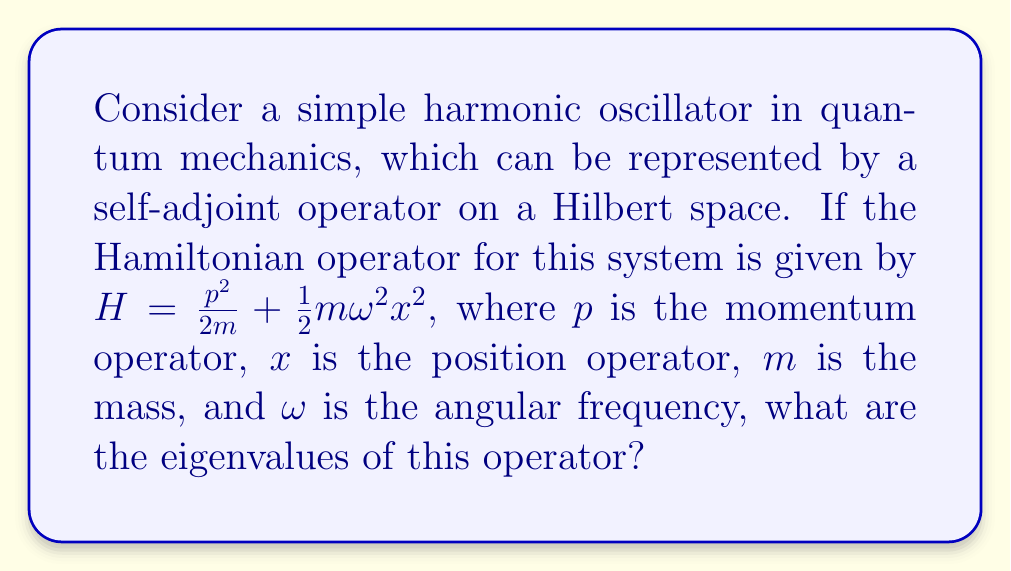Could you help me with this problem? To find the eigenvalues of the Hamiltonian operator, we need to perform a spectral decomposition:

1) The Hamiltonian $H = \frac{p^2}{2m} + \frac{1}{2}m\omega^2x^2$ is a self-adjoint operator on the Hilbert space of square-integrable functions.

2) For the harmonic oscillator, it's known that the eigenvalue equation is:

   $$H\psi_n = E_n\psi_n$$

   where $\psi_n$ are the eigenfunctions and $E_n$ are the eigenvalues.

3) The solution to this equation gives the eigenvalues:

   $$E_n = \hbar\omega(n + \frac{1}{2})$$

   where $n = 0, 1, 2, ...$

4) This means that the energy levels of the harmonic oscillator are quantized, with the lowest energy level (ground state) at $\frac{1}{2}\hbar\omega$ and equally spaced levels above it.

5) The spectral decomposition of $H$ can be written as:

   $$H = \sum_{n=0}^{\infty} E_n |\psi_n\rangle\langle\psi_n|$$

   where $|\psi_n\rangle\langle\psi_n|$ is the projection operator onto the $n$-th eigenstate.

Therefore, the eigenvalues of the Hamiltonian operator for the quantum harmonic oscillator form a discrete spectrum given by $\hbar\omega(n + \frac{1}{2})$ for $n = 0, 1, 2, ...$
Answer: $E_n = \hbar\omega(n + \frac{1}{2})$, $n = 0, 1, 2, ...$ 